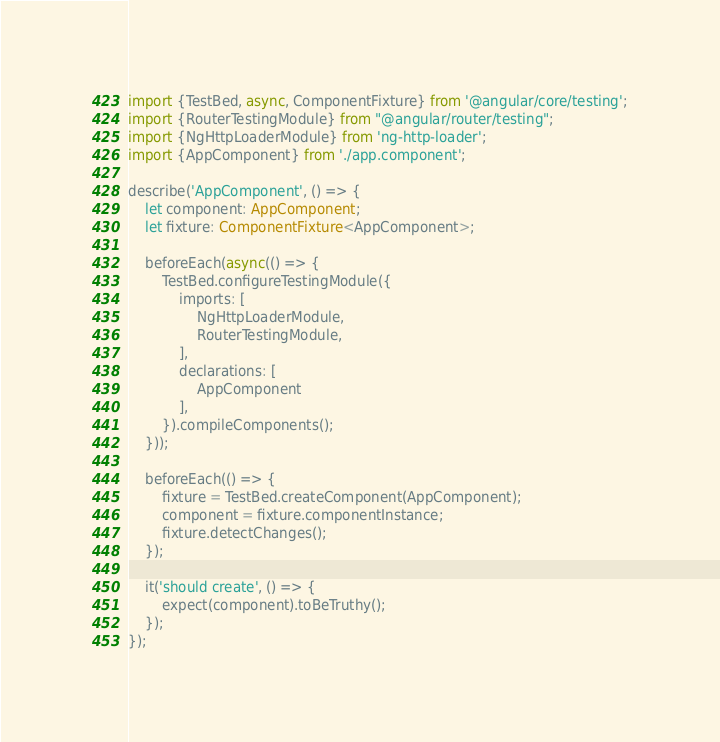<code> <loc_0><loc_0><loc_500><loc_500><_TypeScript_>import {TestBed, async, ComponentFixture} from '@angular/core/testing';
import {RouterTestingModule} from "@angular/router/testing";
import {NgHttpLoaderModule} from 'ng-http-loader';
import {AppComponent} from './app.component';

describe('AppComponent', () => {
    let component: AppComponent;
    let fixture: ComponentFixture<AppComponent>;

    beforeEach(async(() => {
        TestBed.configureTestingModule({
            imports: [
                NgHttpLoaderModule,
                RouterTestingModule,
            ],
            declarations: [
                AppComponent
            ],
        }).compileComponents();
    }));

    beforeEach(() => {
        fixture = TestBed.createComponent(AppComponent);
        component = fixture.componentInstance;
        fixture.detectChanges();
    });

    it('should create', () => {
        expect(component).toBeTruthy();
    });
});
</code> 